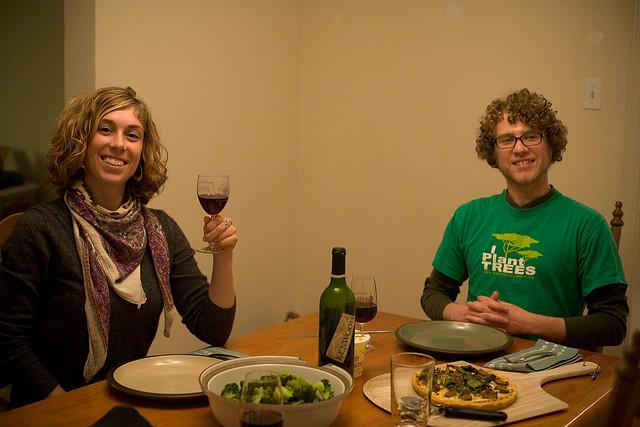What did the person taking the picture say to make the couple smile?
Be succinct. Cheese. Is the man on the right an environmentalist?
Answer briefly. Yes. What does this man's shirt say?
Concise answer only. I plant trees. Is the woman smiling?
Be succinct. Yes. 